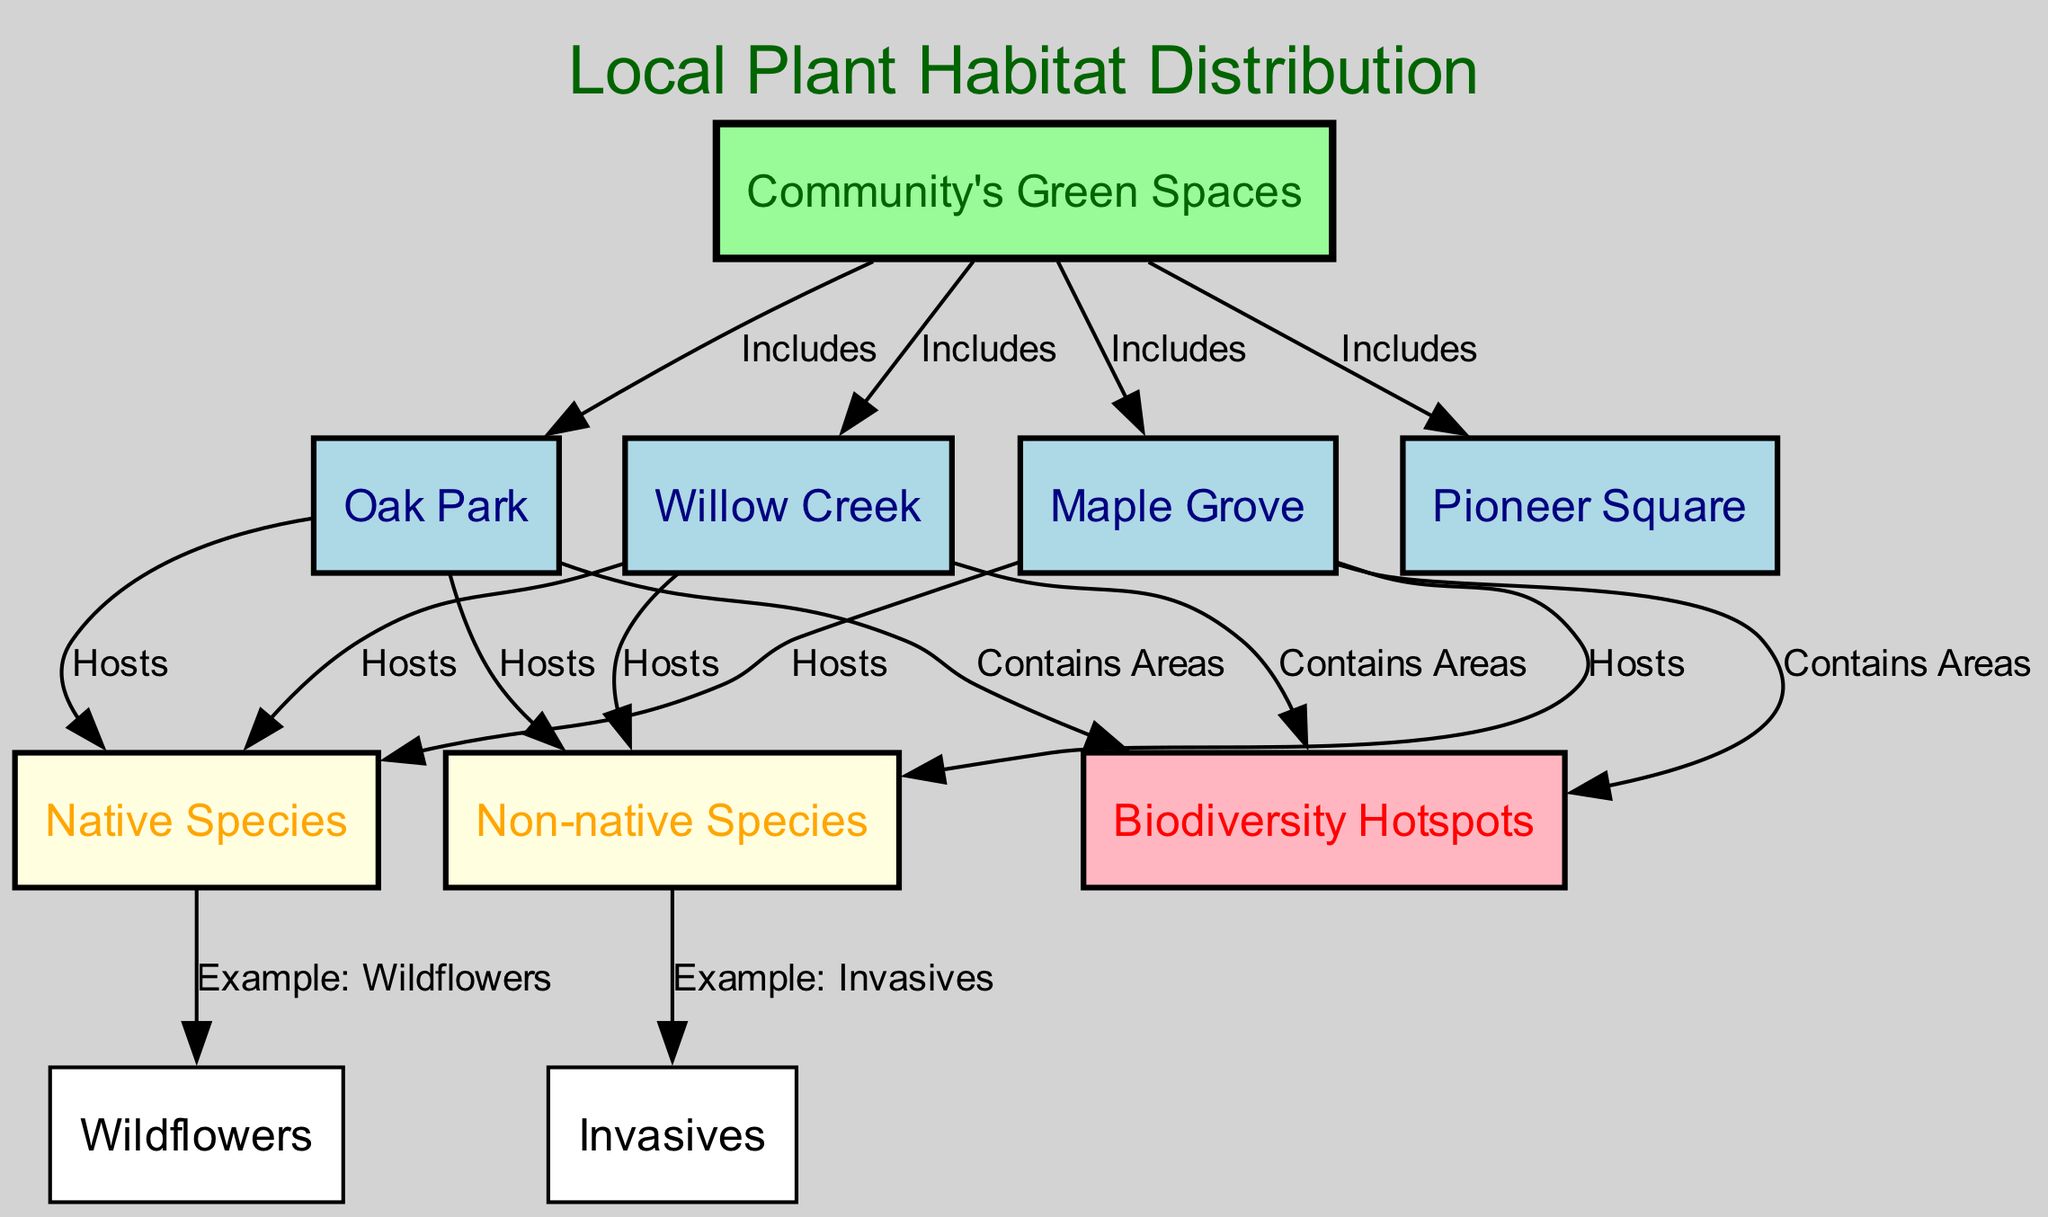what are the four main green spaces in the community? The diagram shows four green spaces depicted as nodes: Oak Park, Maple Grove, Willow Creek, and Pioneer Square. These are all included under the "Community's Green Spaces" node.
Answer: Oak Park, Maple Grove, Willow Creek, Pioneer Square how many types of species are highlighted in the diagram? The diagram identifies two main types of species: Native Species and Non-native Species. These are clearly labeled and represent different ecological categories.
Answer: 2 which section contains wildflowers as an example? The diagram shows that Wildflowers are an example of Native Species, as indicated by an edge from the Native Species node to the Wildflowers node.
Answer: Native Species what do Maple Grove and Willow Creek have in common? Both Maple Grove and Willow Creek are connected to native species indicating they host these types of plants. They also share the characteristic of encompassing biodiversity hotspots as marked in their connections to that node.
Answer: Host native species and contain biodiversity hotspots are invasives associated with native or non-native species? The diagram illustrates that Invasives are a type of Non-native Species. There's a direct edge from the Non-native Species node to the Invasives node, showing their relationship.
Answer: Non-native species which green space does not have a direct edge to the biodiversity hotspots? Looking at the diagram, all listed green spaces have edges leading to the biodiversity hotspots node, which means they are all associated with it. Therefore, there is no green space without this connection.
Answer: None how many edges connect green spaces to species? Each green space connects to both types of species: native and non-native. Since there are four green spaces, and each type has a connection to both, this results in 4 green spaces x 2 species types = 8 edges.
Answer: 8 which biodiversity hotspot is found in the community's green spaces? From the diagram, the edges indicate that all three green spaces, Oak Park, Maple Grove, and Willow Creek, contain biodiversity hotspots, but the diagram does not specify particular hotspots' names.
Answer: Not specified 